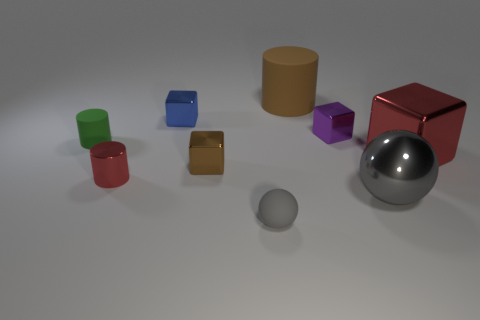Subtract all tiny cylinders. How many cylinders are left? 1 Subtract all cyan blocks. Subtract all green cylinders. How many blocks are left? 4 Add 1 purple blocks. How many objects exist? 10 Subtract all small brown blocks. Subtract all big brown metal things. How many objects are left? 8 Add 2 metallic cylinders. How many metallic cylinders are left? 3 Add 9 small purple shiny blocks. How many small purple shiny blocks exist? 10 Subtract 1 red cylinders. How many objects are left? 8 Subtract all cylinders. How many objects are left? 6 